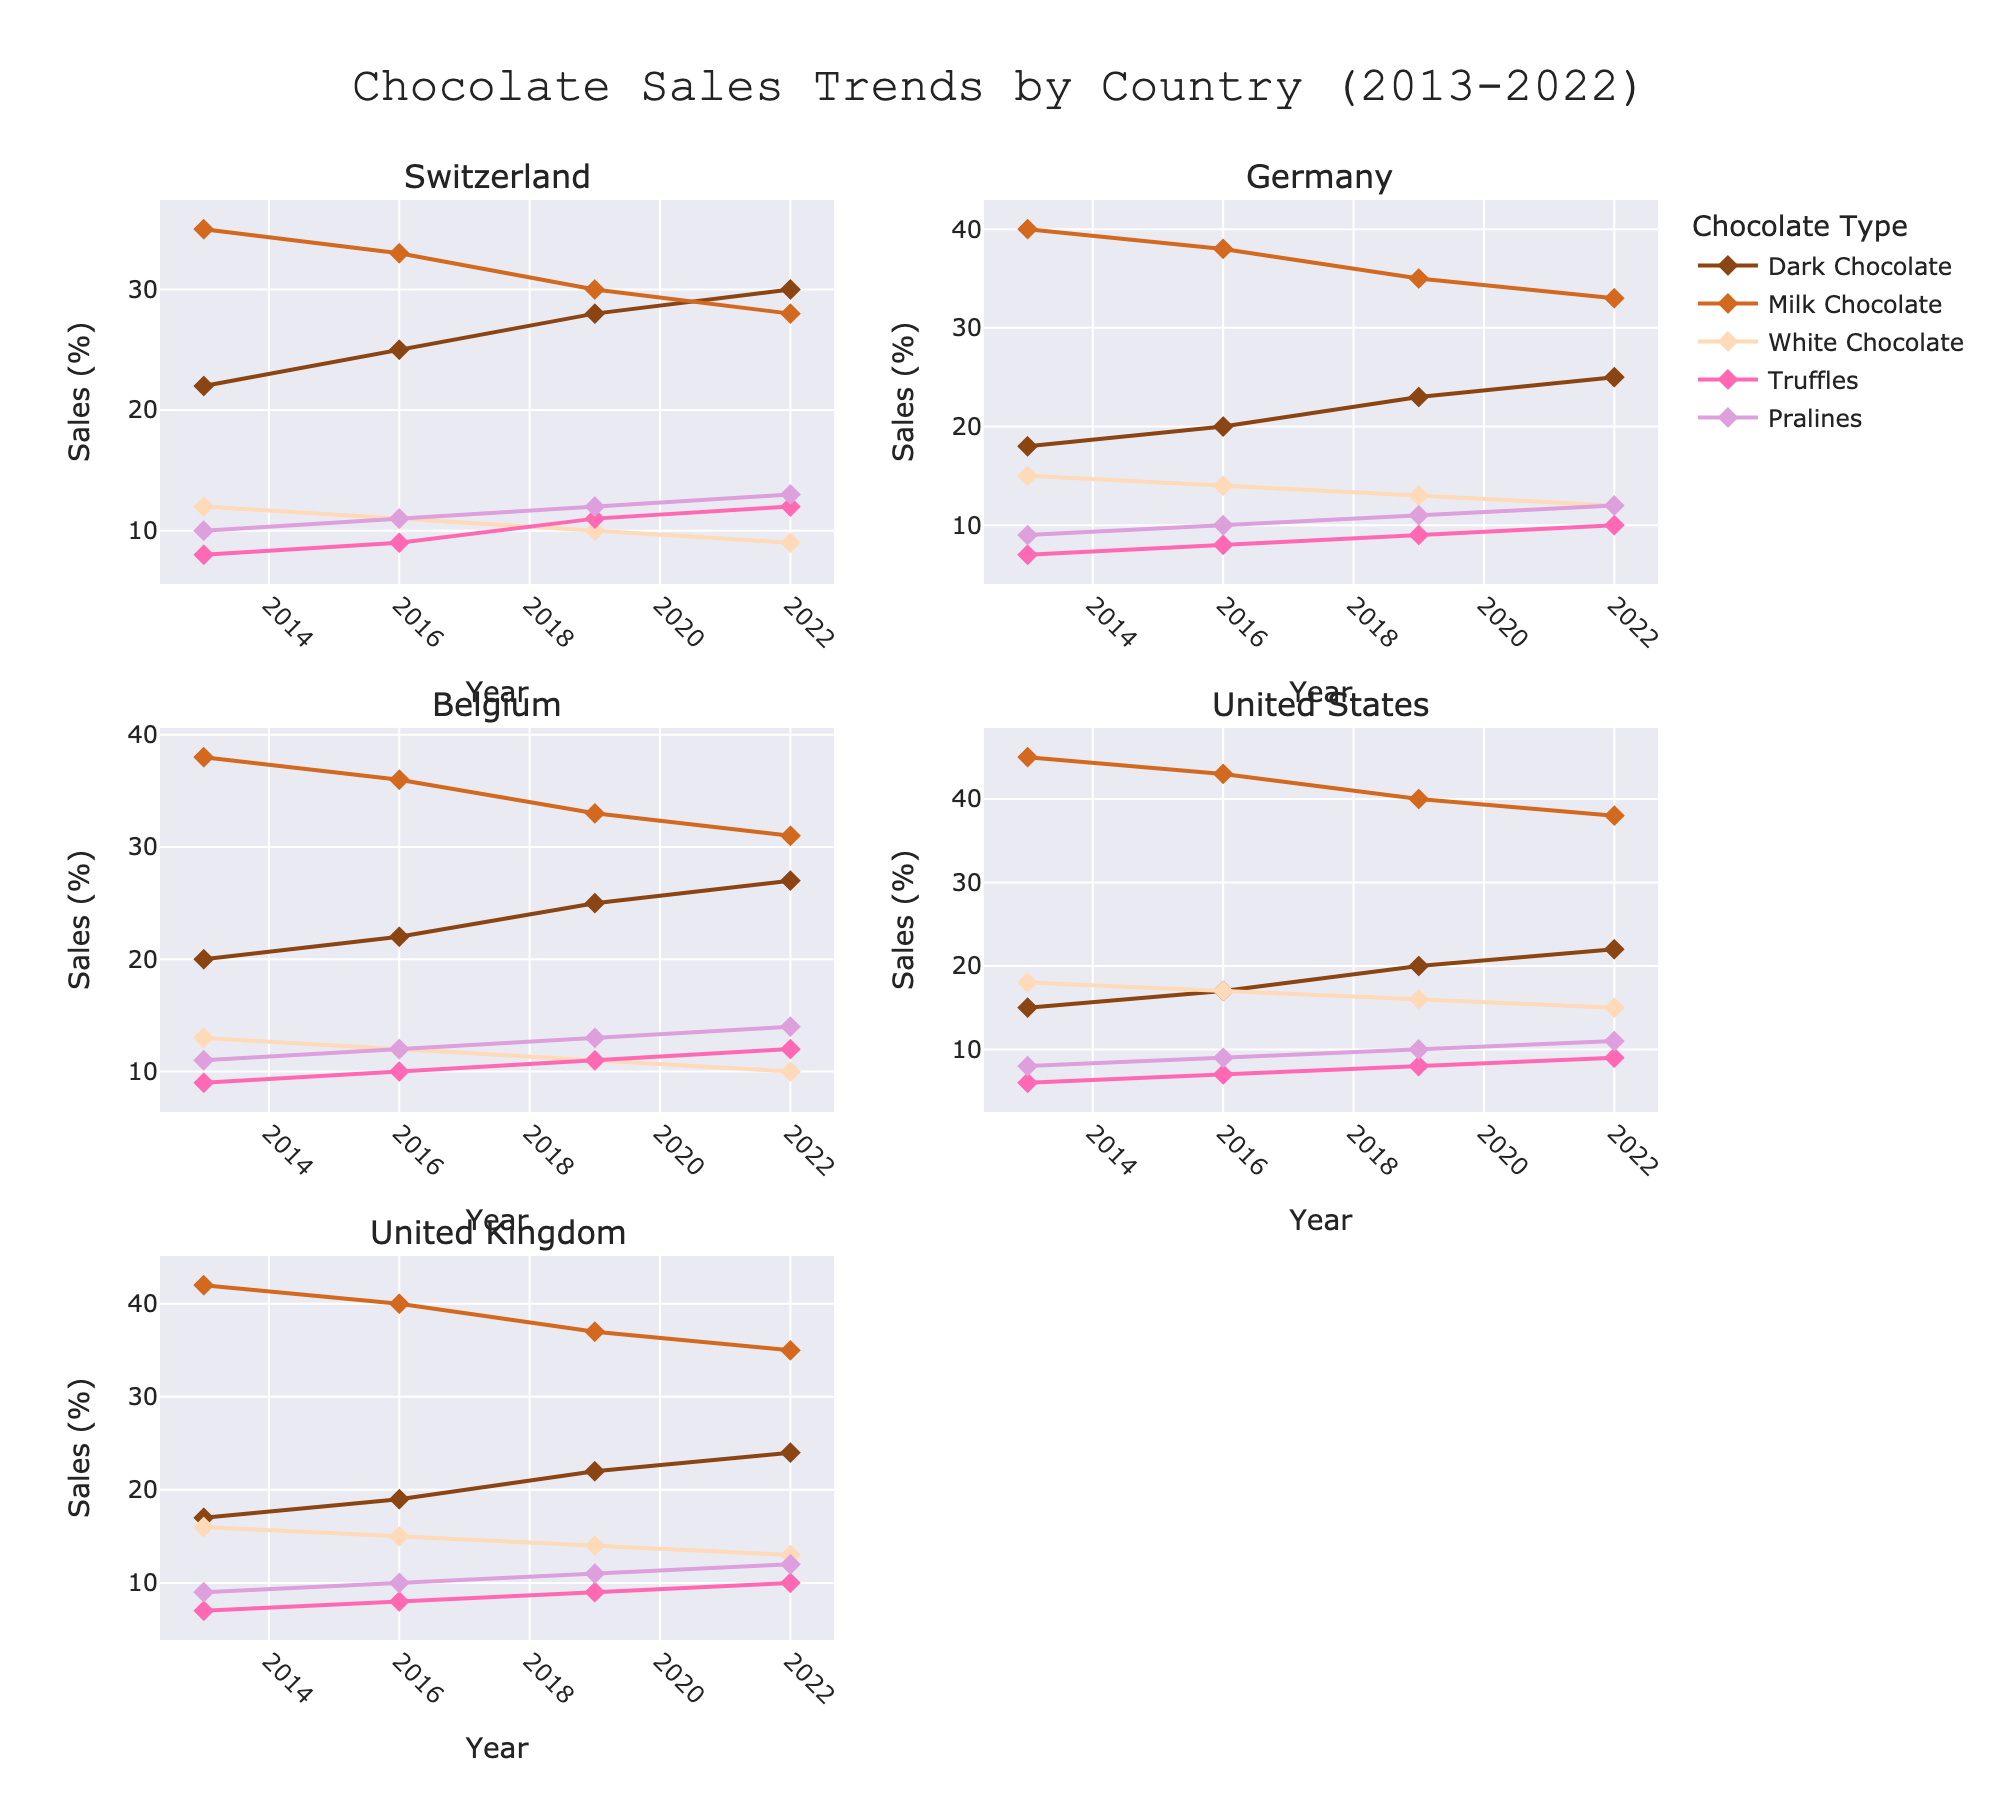How many countries are represented in the figure? There are 5 subplot titles, each corresponding to a country.
Answer: 5 Which chocolate type has the highest sales percentage in the United States in 2013? By checking the subplot for the United States at the year 2013, the chocolate type with the highest sales is Milk Chocolate with 45%.
Answer: Milk Chocolate For Switzerland, how did the sales of Dark Chocolate change from 2013 to 2022? In the Switzerland subplot, Dark Chocolate sales increased from 22% in 2013 to 30% in 2022.
Answer: Increased Compare the sales trends of White Chocolate between 2013 and 2022 for Germany and Belgium. Which country saw a greater decrease? Germany's White Chocolate sales dropped from 15% to 12%, a decrease of 3%. Belgium's sales decreased from 13% to 10%, a decrease of 3%. So, both countries saw the same decrease.
Answer: Same In the subplot for the United Kingdom, which year saw the largest increase in Truffles sales compared to the previous year? For the United Kingdom subplot, comparing changes in Truffles sales year-on-year, the largest increase was from 2019 to 2022 (7% to 10%).
Answer: 2022 What is the overall trend for Pralines sales in Belgium from 2013 to 2022? Observing the Belgium subplot, the sales of Pralines increased steadily from 11% in 2013 to 14% in 2022.
Answer: Increased Which country had the lowest sales of Dark Chocolate in 2022? Looking at Dark Chocolate sales in 2022 for all countries, the United States had the lowest at 22%.
Answer: United States Calculate the average sales of Milk Chocolate in Germany over the decade. Summing the Milk Chocolate sales for Germany (40, 38, 35, 33) and dividing by the number of years (4), the average is (40 + 38 + 35 + 33) / 4 = 36.5%.
Answer: 36.5% Between the years 2019 and 2022, which country experienced the most significant decrease in Milk Chocolate sales? For the years 2019 to 2022, the changes in Milk Chocolate sales were: Switzerland (30 to 28, a decrease of 2), Germany (35 to 33, a decrease of 2), Belgium (33 to 31, a decrease of 2), United States (40 to 38, a decrease of 2), United Kingdom (37 to 35, a decrease of 2). All countries had the same decrease.
Answer: All countries had the same decrease What is the median sales percentage of Truffles in Belgium over the decade? The sales percentages for Truffles in Belgium are 9, 10, 11, and 12. When these values are ordered (9, 10, 11, 12), the median is the average of the two middle numbers (10 and 11), which makes (10+11)/2 = 10.5%.
Answer: 10.5% 